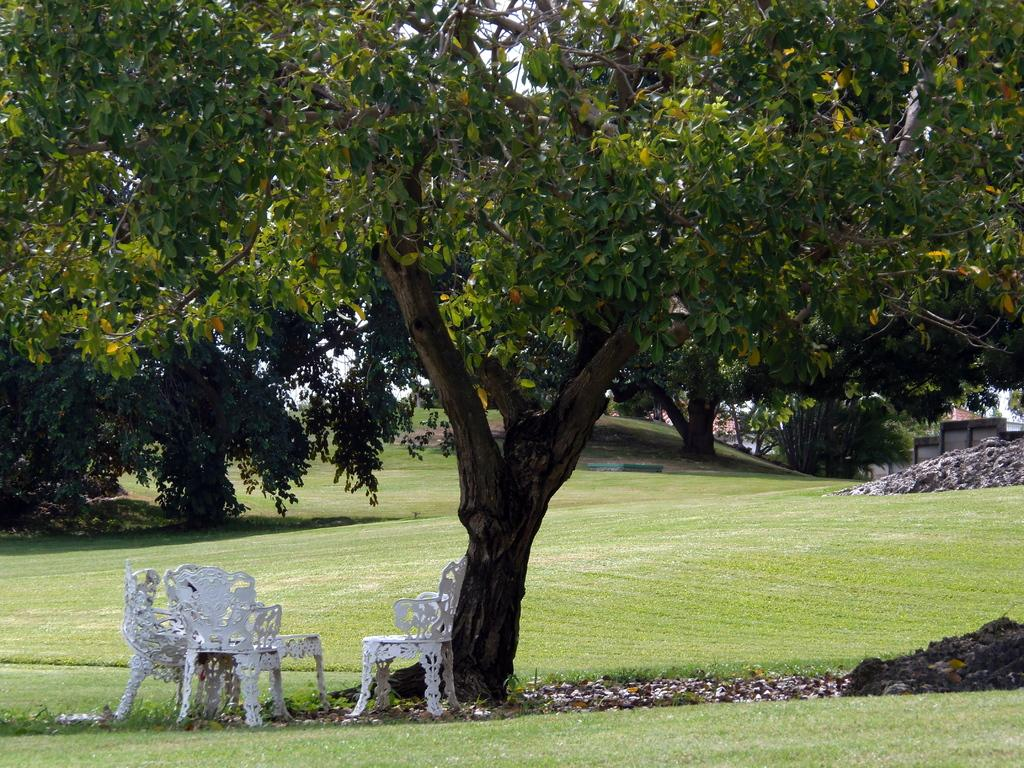What type of vegetation can be seen in the image? There are trees and grass in the image. What type of structures are present in the image? There are houses and a table in the image. What type of furniture is visible in the image? There are chairs in the image. What part of the natural environment is visible in the image? The ground and sky are visible in the image. What is the surface on which the chairs and table are placed? The ground is visible with some objects, including the chairs and table. What type of organization is depicted in the image? There is no organization depicted in the image; it features trees, houses, chairs, a table, and grass. 